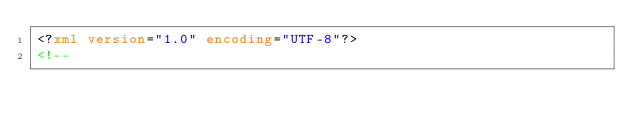<code> <loc_0><loc_0><loc_500><loc_500><_XML_><?xml version="1.0" encoding="UTF-8"?>
<!--
</code> 